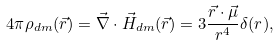Convert formula to latex. <formula><loc_0><loc_0><loc_500><loc_500>4 \pi \rho _ { d m } ( \vec { r } ) = \vec { \nabla } \cdot \vec { H } _ { d m } ( \vec { r } ) = 3 \frac { \vec { r } \cdot \vec { \mu } } { r ^ { 4 } } \delta ( r ) ,</formula> 